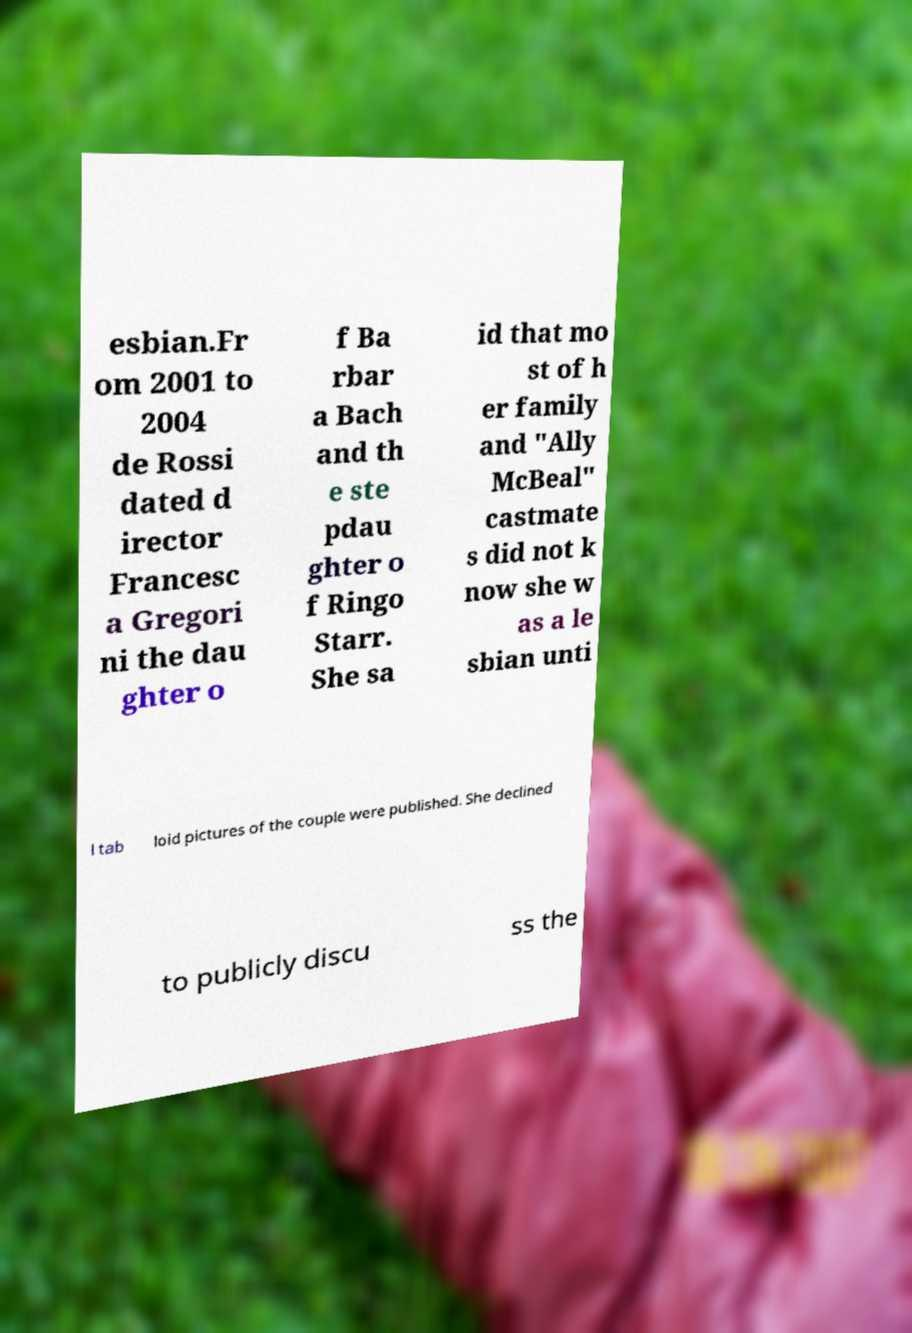Could you assist in decoding the text presented in this image and type it out clearly? esbian.Fr om 2001 to 2004 de Rossi dated d irector Francesc a Gregori ni the dau ghter o f Ba rbar a Bach and th e ste pdau ghter o f Ringo Starr. She sa id that mo st of h er family and "Ally McBeal" castmate s did not k now she w as a le sbian unti l tab loid pictures of the couple were published. She declined to publicly discu ss the 